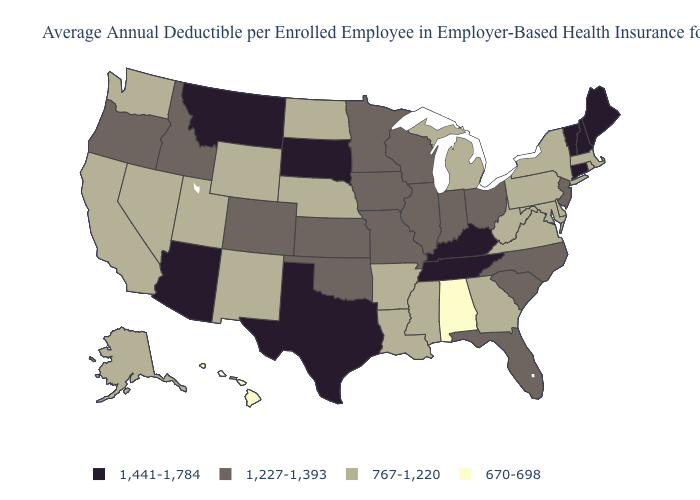Does Michigan have a higher value than Alabama?
Keep it brief. Yes. Among the states that border Florida , which have the lowest value?
Concise answer only. Alabama. Which states have the lowest value in the USA?
Write a very short answer. Alabama, Hawaii. Among the states that border South Carolina , does Georgia have the highest value?
Give a very brief answer. No. Does Alabama have the lowest value in the USA?
Answer briefly. Yes. What is the value of Tennessee?
Be succinct. 1,441-1,784. Which states have the highest value in the USA?
Write a very short answer. Arizona, Connecticut, Kentucky, Maine, Montana, New Hampshire, South Dakota, Tennessee, Texas, Vermont. Does Alabama have a lower value than Kentucky?
Write a very short answer. Yes. What is the highest value in the South ?
Quick response, please. 1,441-1,784. How many symbols are there in the legend?
Quick response, please. 4. Name the states that have a value in the range 1,227-1,393?
Quick response, please. Colorado, Florida, Idaho, Illinois, Indiana, Iowa, Kansas, Minnesota, Missouri, New Jersey, North Carolina, Ohio, Oklahoma, Oregon, South Carolina, Wisconsin. Which states have the highest value in the USA?
Answer briefly. Arizona, Connecticut, Kentucky, Maine, Montana, New Hampshire, South Dakota, Tennessee, Texas, Vermont. Which states hav the highest value in the South?
Concise answer only. Kentucky, Tennessee, Texas. How many symbols are there in the legend?
Quick response, please. 4. What is the value of Massachusetts?
Short answer required. 767-1,220. 